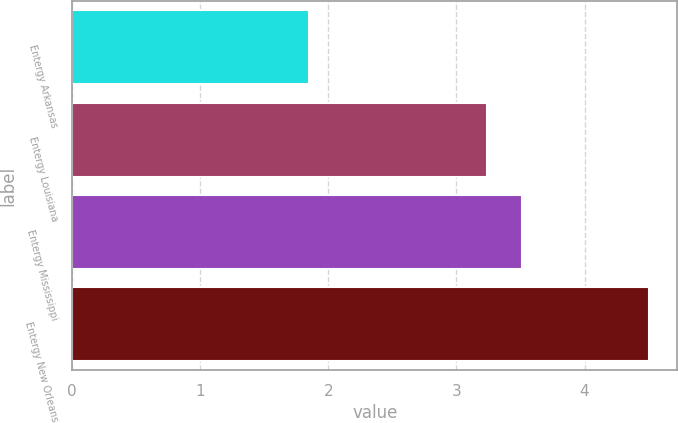<chart> <loc_0><loc_0><loc_500><loc_500><bar_chart><fcel>Entergy Arkansas<fcel>Entergy Louisiana<fcel>Entergy Mississippi<fcel>Entergy New Orleans<nl><fcel>1.85<fcel>3.24<fcel>3.51<fcel>4.5<nl></chart> 